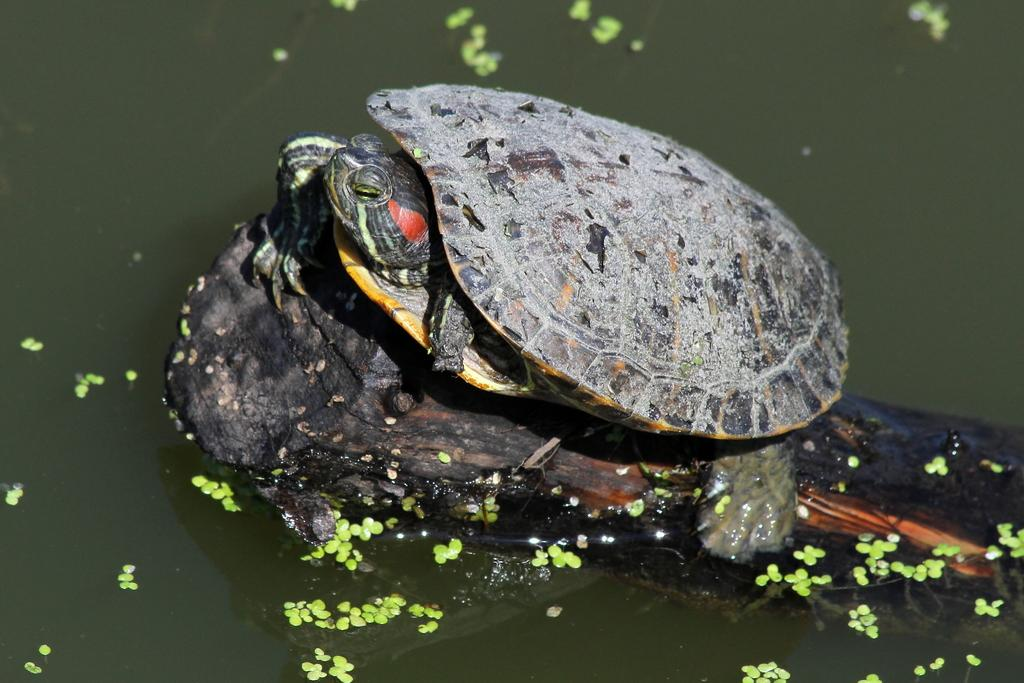What animal is present in the image? There is a turtle in the image. Where is the turtle located? The turtle is on a tree trunk. What is the condition of the tree trunk in the image? The tree trunk is submerged in water. What else can be seen floating on the water in the image? There are leaves on the water in the image. What type of news can be heard coming from the turtle in the image? There is no indication in the image that the turtle is making any sounds, let alone conveying news. 